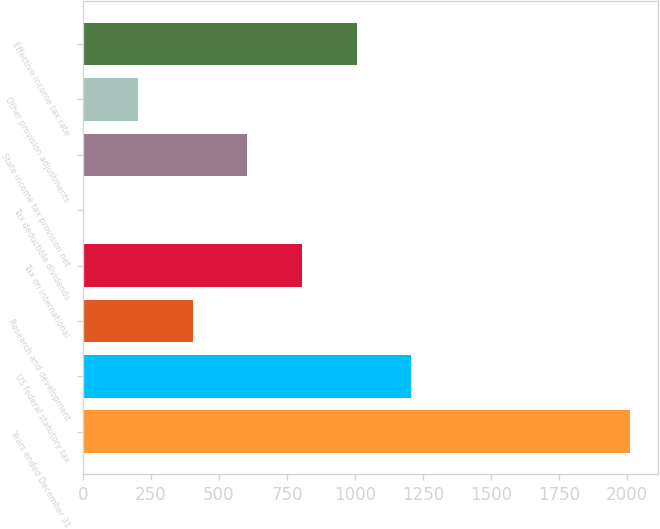Convert chart. <chart><loc_0><loc_0><loc_500><loc_500><bar_chart><fcel>Years ended December 31<fcel>US federal statutory tax<fcel>Research and development<fcel>Tax on international<fcel>Tax deductible dividends<fcel>State income tax provision net<fcel>Other provision adjustments<fcel>Effective income tax rate<nl><fcel>2012<fcel>1207.48<fcel>402.96<fcel>805.22<fcel>0.7<fcel>604.09<fcel>201.83<fcel>1006.35<nl></chart> 